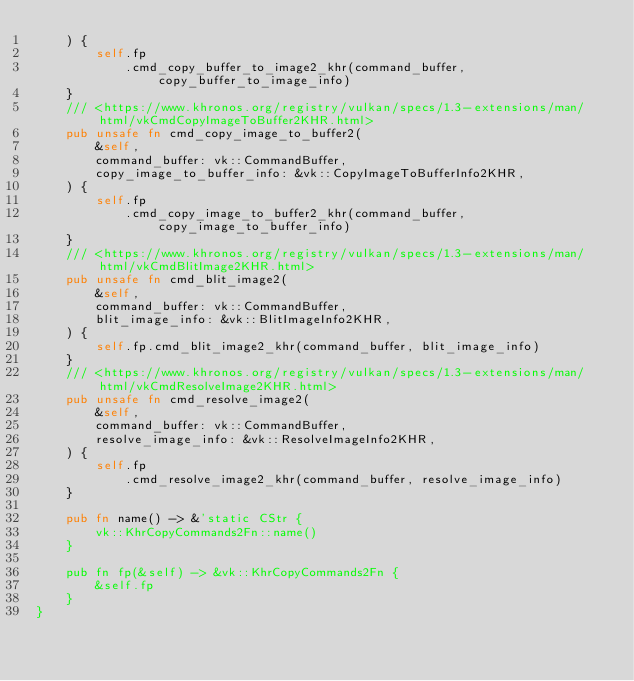Convert code to text. <code><loc_0><loc_0><loc_500><loc_500><_Rust_>    ) {
        self.fp
            .cmd_copy_buffer_to_image2_khr(command_buffer, copy_buffer_to_image_info)
    }
    /// <https://www.khronos.org/registry/vulkan/specs/1.3-extensions/man/html/vkCmdCopyImageToBuffer2KHR.html>
    pub unsafe fn cmd_copy_image_to_buffer2(
        &self,
        command_buffer: vk::CommandBuffer,
        copy_image_to_buffer_info: &vk::CopyImageToBufferInfo2KHR,
    ) {
        self.fp
            .cmd_copy_image_to_buffer2_khr(command_buffer, copy_image_to_buffer_info)
    }
    /// <https://www.khronos.org/registry/vulkan/specs/1.3-extensions/man/html/vkCmdBlitImage2KHR.html>
    pub unsafe fn cmd_blit_image2(
        &self,
        command_buffer: vk::CommandBuffer,
        blit_image_info: &vk::BlitImageInfo2KHR,
    ) {
        self.fp.cmd_blit_image2_khr(command_buffer, blit_image_info)
    }
    /// <https://www.khronos.org/registry/vulkan/specs/1.3-extensions/man/html/vkCmdResolveImage2KHR.html>
    pub unsafe fn cmd_resolve_image2(
        &self,
        command_buffer: vk::CommandBuffer,
        resolve_image_info: &vk::ResolveImageInfo2KHR,
    ) {
        self.fp
            .cmd_resolve_image2_khr(command_buffer, resolve_image_info)
    }

    pub fn name() -> &'static CStr {
        vk::KhrCopyCommands2Fn::name()
    }

    pub fn fp(&self) -> &vk::KhrCopyCommands2Fn {
        &self.fp
    }
}
</code> 